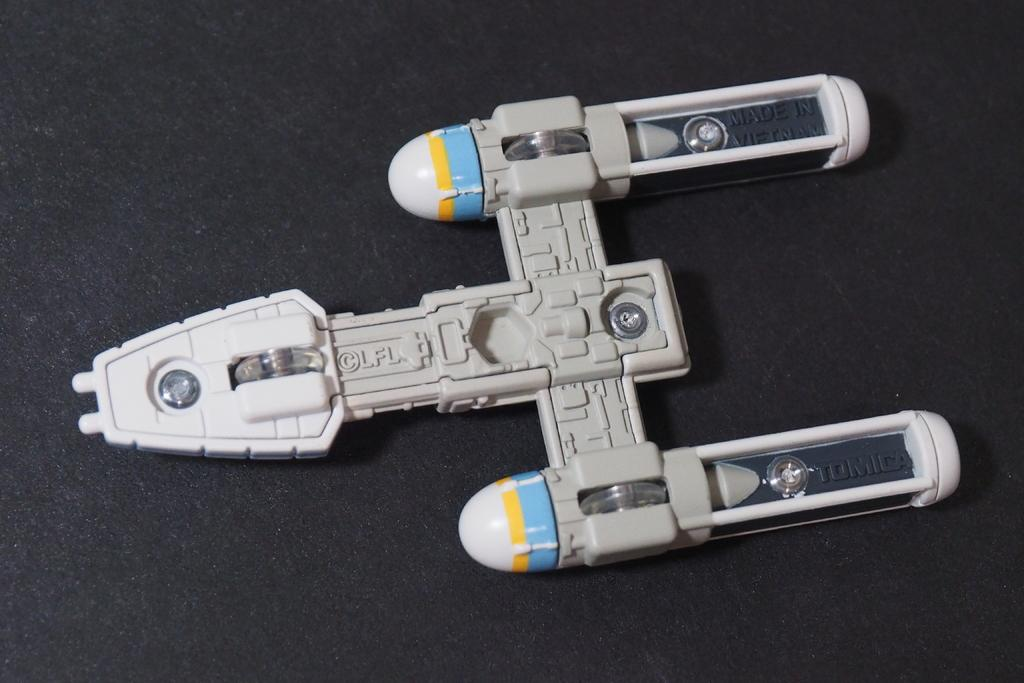What is the color of the object in the image? The object in the image is white. What is the color of the surface the object is on? The surface the object is on is black. Are there any dinosaurs visible in the image? No, there are no dinosaurs present in the image. Can you tell me how many times the object has been crushed in the image? The object has not been crushed in the image, so it is not possible to determine how many times it has been crushed. 